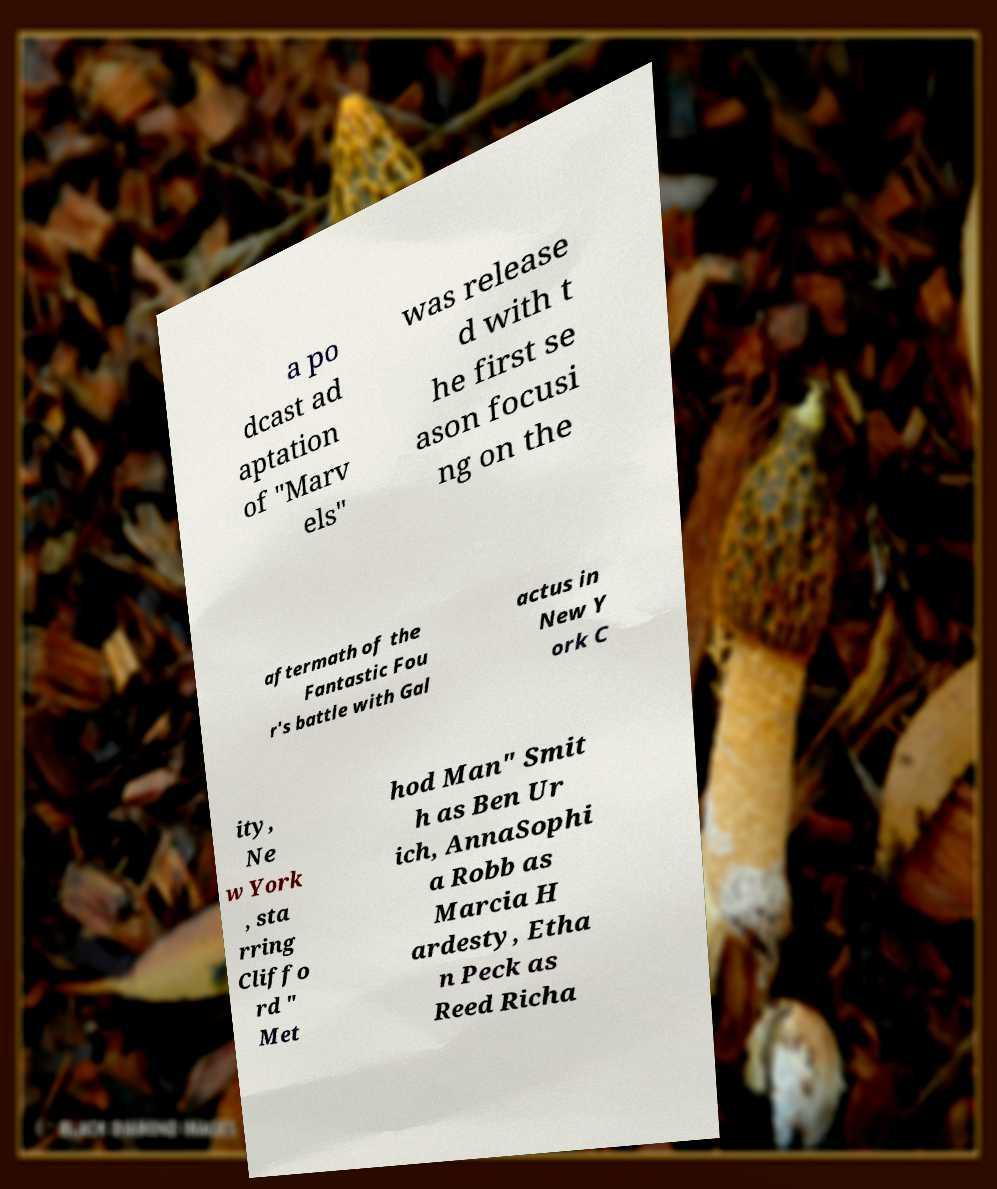Please identify and transcribe the text found in this image. a po dcast ad aptation of "Marv els" was release d with t he first se ason focusi ng on the aftermath of the Fantastic Fou r's battle with Gal actus in New Y ork C ity, Ne w York , sta rring Cliffo rd " Met hod Man" Smit h as Ben Ur ich, AnnaSophi a Robb as Marcia H ardesty, Etha n Peck as Reed Richa 